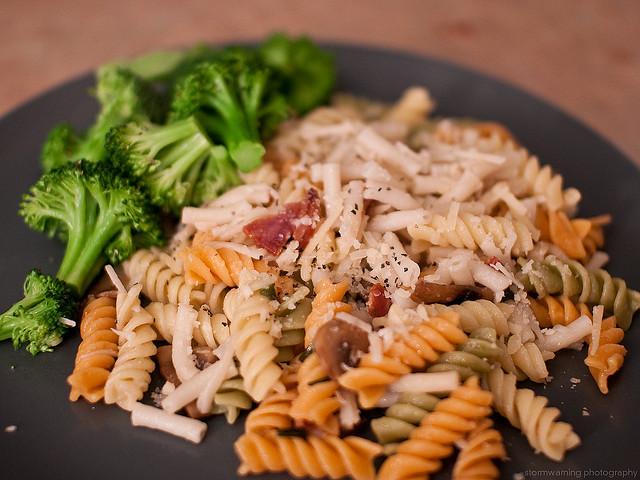What is the green vegetable?
Answer briefly. Broccoli. Are there carrots in this dish?
Keep it brief. No. What is the dressing of the salad?
Give a very brief answer. Cheese. What color is the plate?
Answer briefly. Black. What kind of cuisine is this?
Answer briefly. Pasta. What kind of pasta is in the dish?
Write a very short answer. Spiral. Is this salty?
Quick response, please. No. What veggies are seen?
Answer briefly. Broccoli. What is under the plate?
Answer briefly. Table. What kind of food is shown?
Give a very brief answer. Pasta. 